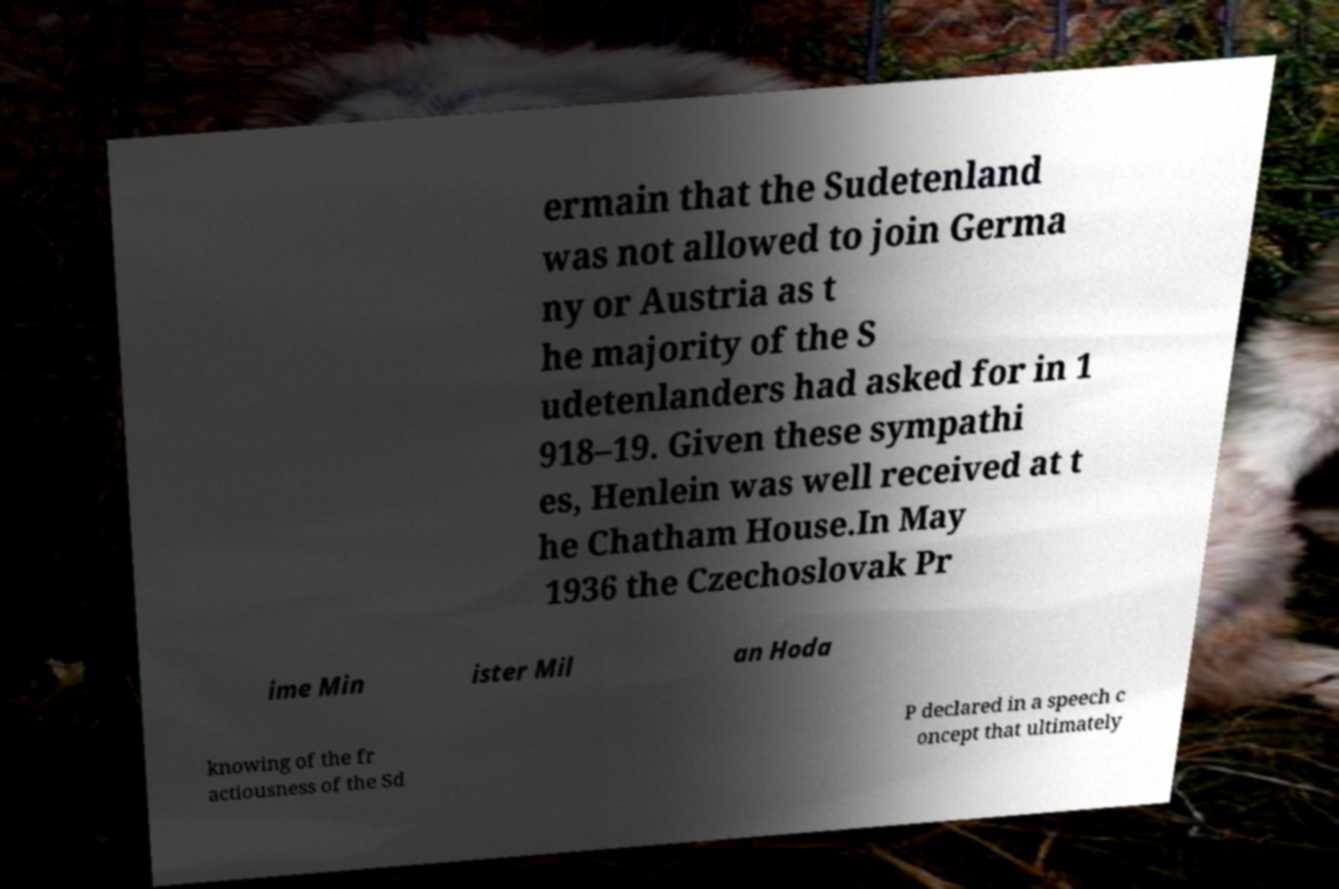I need the written content from this picture converted into text. Can you do that? ermain that the Sudetenland was not allowed to join Germa ny or Austria as t he majority of the S udetenlanders had asked for in 1 918–19. Given these sympathi es, Henlein was well received at t he Chatham House.In May 1936 the Czechoslovak Pr ime Min ister Mil an Hoda knowing of the fr actiousness of the Sd P declared in a speech c oncept that ultimately 